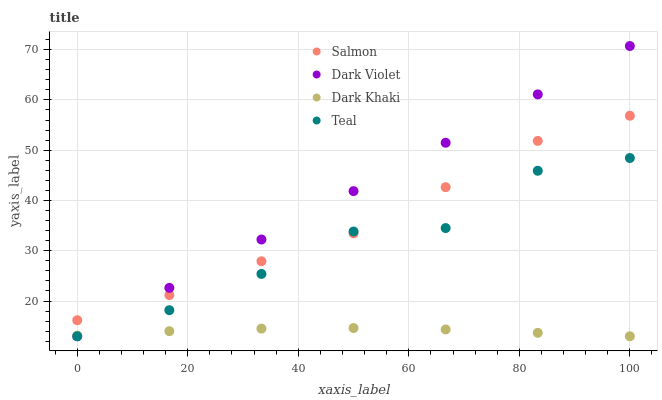Does Dark Khaki have the minimum area under the curve?
Answer yes or no. Yes. Does Dark Violet have the maximum area under the curve?
Answer yes or no. Yes. Does Salmon have the minimum area under the curve?
Answer yes or no. No. Does Salmon have the maximum area under the curve?
Answer yes or no. No. Is Dark Violet the smoothest?
Answer yes or no. Yes. Is Teal the roughest?
Answer yes or no. Yes. Is Salmon the smoothest?
Answer yes or no. No. Is Salmon the roughest?
Answer yes or no. No. Does Dark Khaki have the lowest value?
Answer yes or no. Yes. Does Salmon have the lowest value?
Answer yes or no. No. Does Dark Violet have the highest value?
Answer yes or no. Yes. Does Salmon have the highest value?
Answer yes or no. No. Is Dark Khaki less than Salmon?
Answer yes or no. Yes. Is Salmon greater than Dark Khaki?
Answer yes or no. Yes. Does Teal intersect Dark Khaki?
Answer yes or no. Yes. Is Teal less than Dark Khaki?
Answer yes or no. No. Is Teal greater than Dark Khaki?
Answer yes or no. No. Does Dark Khaki intersect Salmon?
Answer yes or no. No. 